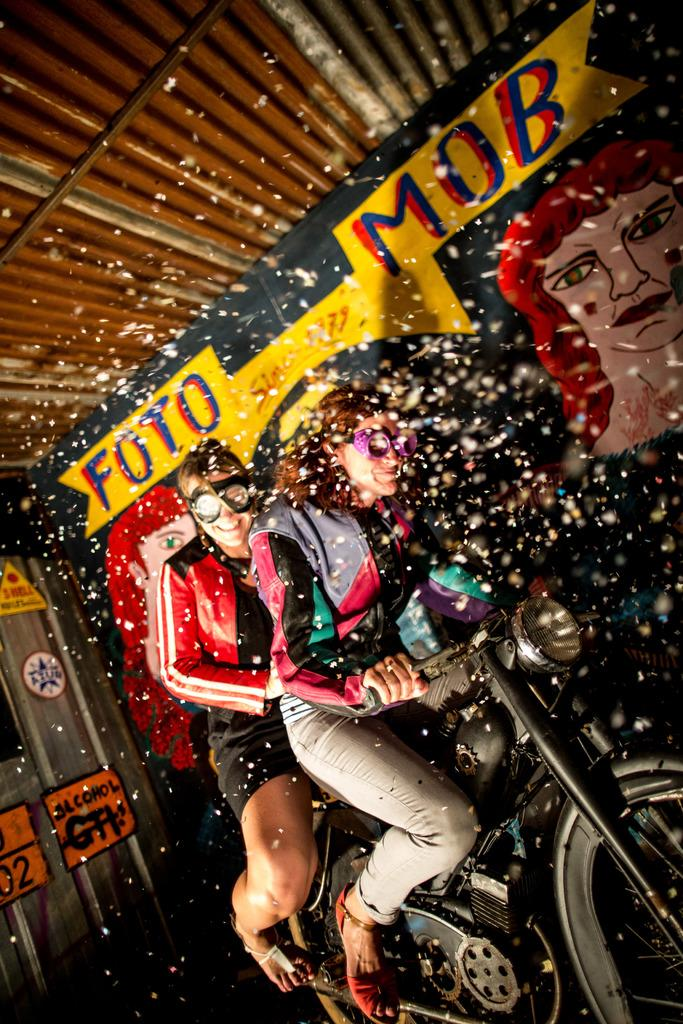How many people are in the image? There are two people in the image. What are the two people doing in the image? The two people are sitting on a motorcycle. What can be seen in the background of the image? There is a banner in the background of the image. What statement is being made by the thumb in the image? There is no thumb present in the image, so no statement can be made by it. 